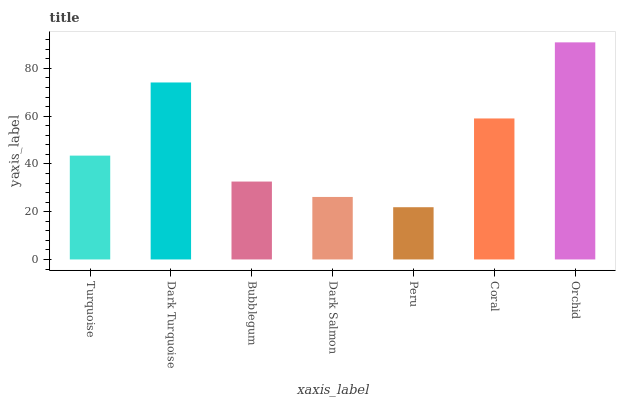Is Peru the minimum?
Answer yes or no. Yes. Is Orchid the maximum?
Answer yes or no. Yes. Is Dark Turquoise the minimum?
Answer yes or no. No. Is Dark Turquoise the maximum?
Answer yes or no. No. Is Dark Turquoise greater than Turquoise?
Answer yes or no. Yes. Is Turquoise less than Dark Turquoise?
Answer yes or no. Yes. Is Turquoise greater than Dark Turquoise?
Answer yes or no. No. Is Dark Turquoise less than Turquoise?
Answer yes or no. No. Is Turquoise the high median?
Answer yes or no. Yes. Is Turquoise the low median?
Answer yes or no. Yes. Is Coral the high median?
Answer yes or no. No. Is Peru the low median?
Answer yes or no. No. 